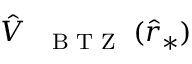Convert formula to latex. <formula><loc_0><loc_0><loc_500><loc_500>\hat { V } _ { { B T Z } } ( \hat { r } _ { * } )</formula> 